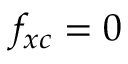<formula> <loc_0><loc_0><loc_500><loc_500>f _ { x c } = 0</formula> 